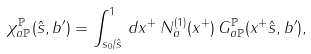Convert formula to latex. <formula><loc_0><loc_0><loc_500><loc_500>\chi _ { a { \mathbb { P } } } ^ { \mathbb { P } } ( \hat { s } , b ^ { \prime } ) = \int _ { s _ { 0 } / \hat { s } } ^ { 1 } \, d x ^ { + } \, N _ { a } ^ { ( 1 ) } ( x ^ { + } ) \, G _ { a { \mathbb { P } } } ^ { \mathbb { P } } ( x ^ { + } \hat { s } , b ^ { \prime } ) ,</formula> 